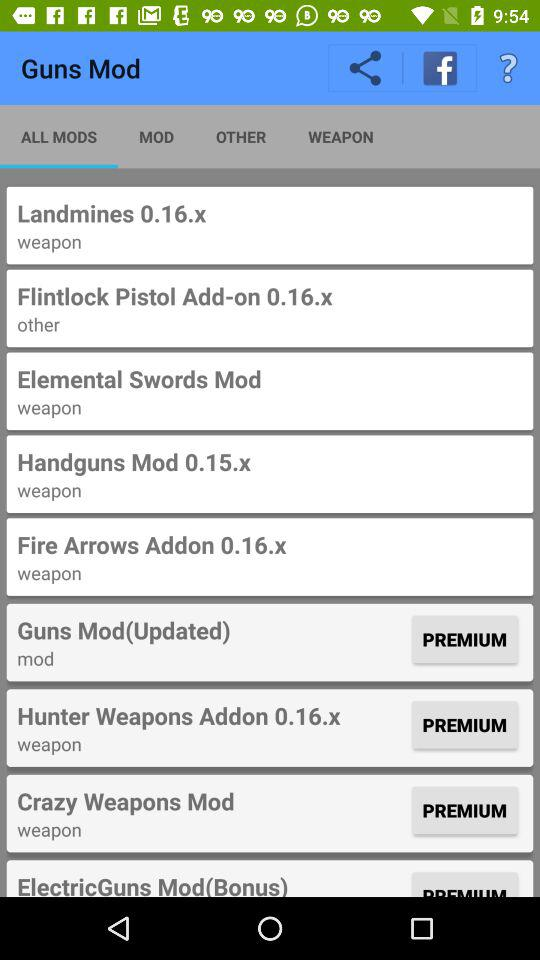What is the selected tab? The selected tab is "ALL MODS". 